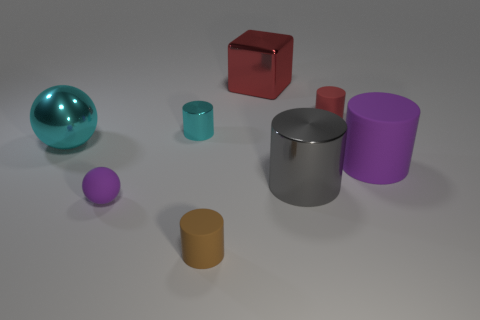Add 2 tiny red matte cylinders. How many objects exist? 10 Subtract all cyan cylinders. How many cylinders are left? 4 Subtract all cyan balls. How many balls are left? 1 Subtract all balls. How many objects are left? 6 Subtract 4 cylinders. How many cylinders are left? 1 Subtract 0 cyan blocks. How many objects are left? 8 Subtract all blue blocks. Subtract all red cylinders. How many blocks are left? 1 Subtract all cyan cylinders. How many purple balls are left? 1 Subtract all small purple rubber balls. Subtract all blocks. How many objects are left? 6 Add 6 small purple matte things. How many small purple matte things are left? 7 